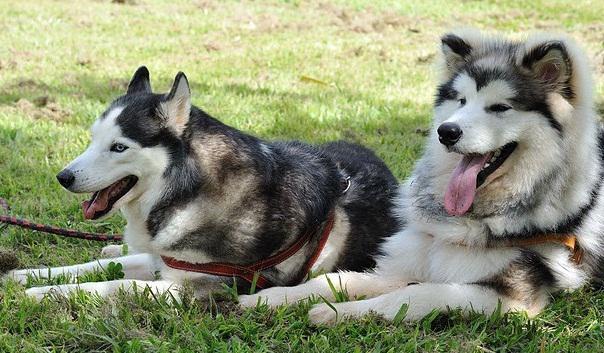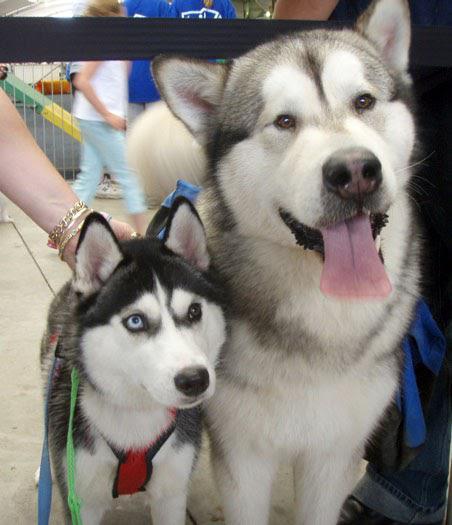The first image is the image on the left, the second image is the image on the right. Assess this claim about the two images: "At least one photo has two dogs, and at least three dogs have their mouths open.". Correct or not? Answer yes or no. Yes. 